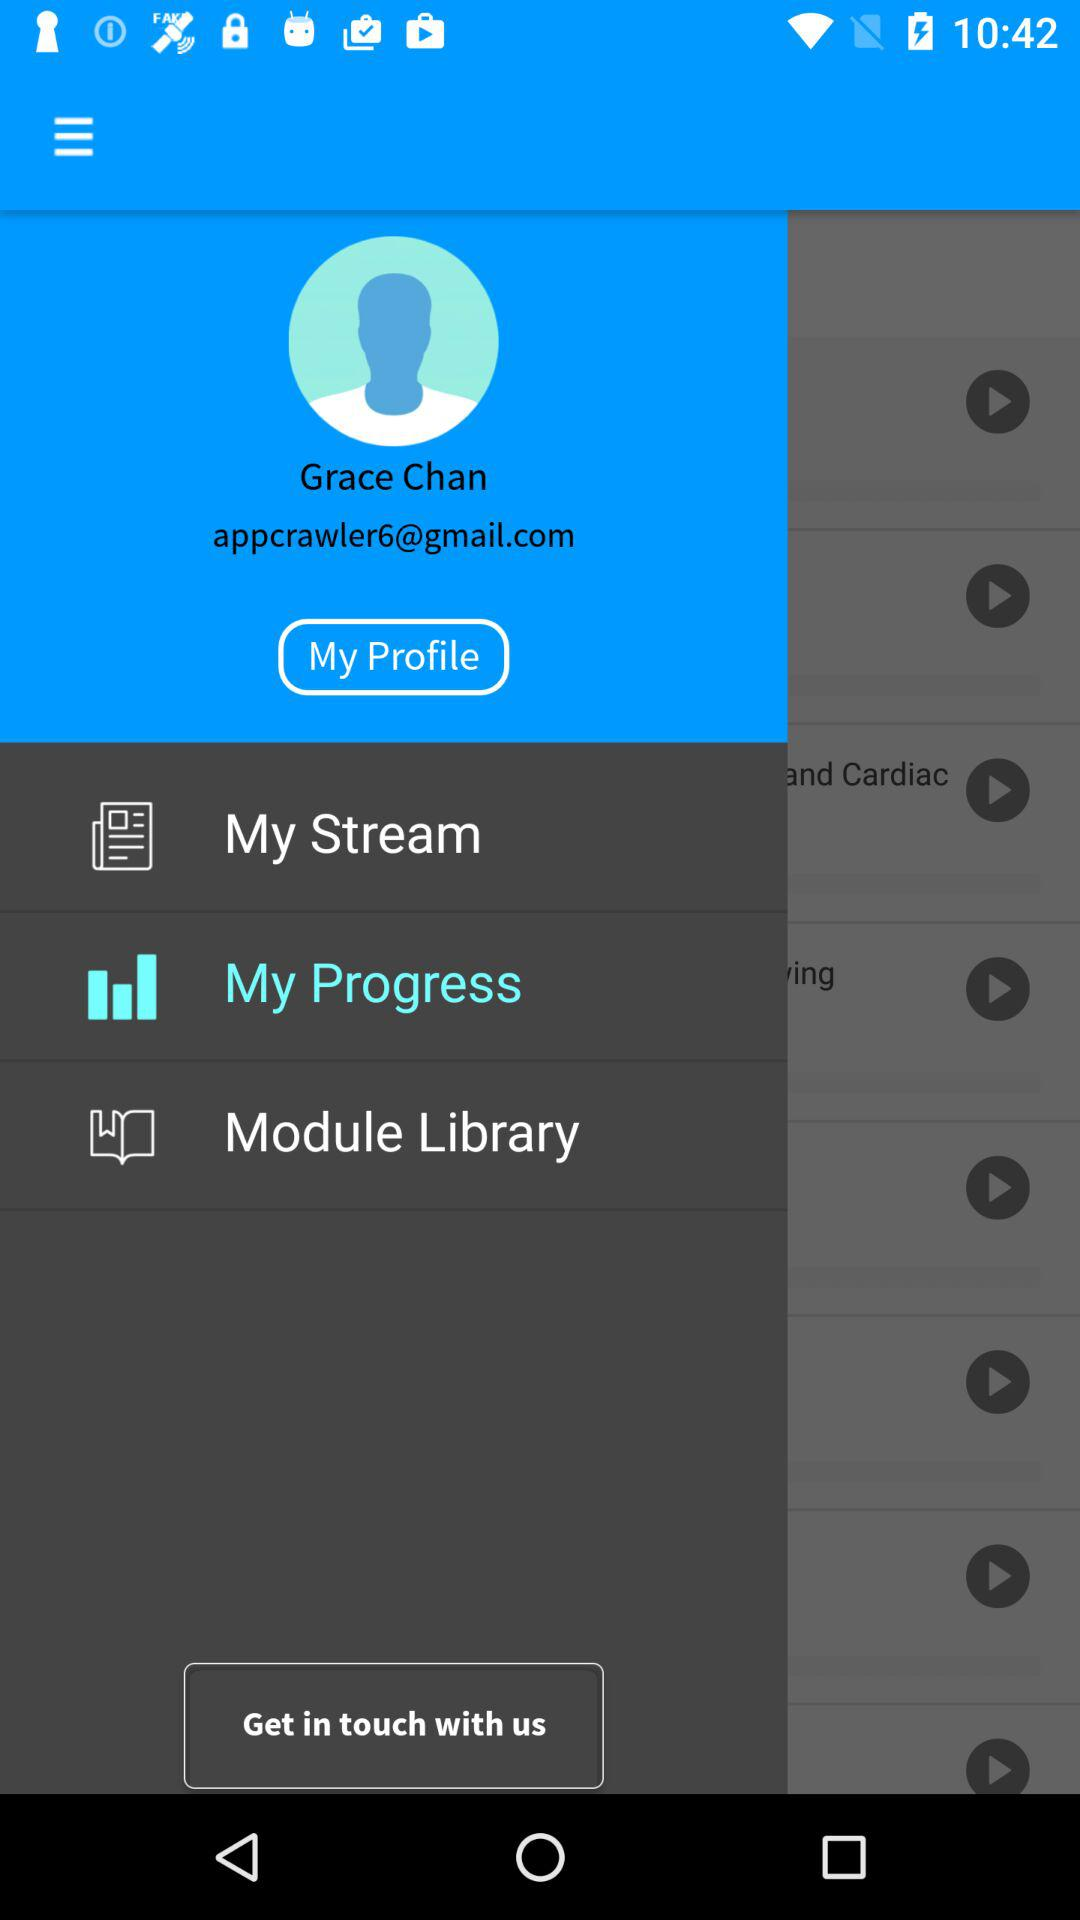What is the email address? The email address is appcrawler6@gmail.com. 